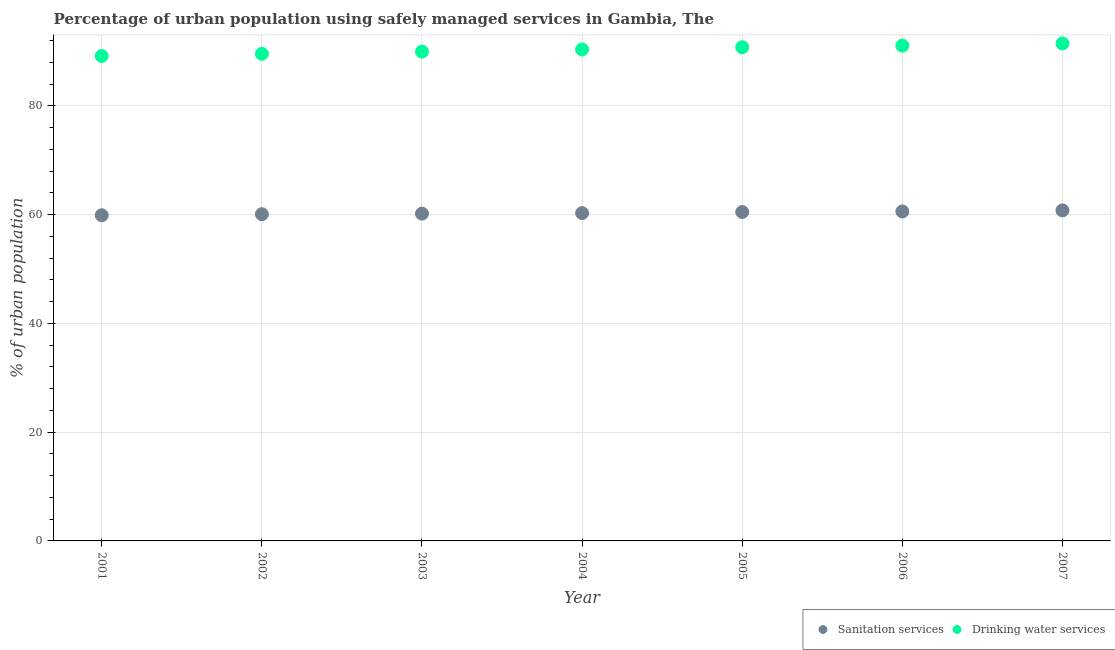What is the percentage of urban population who used drinking water services in 2006?
Make the answer very short. 91.1. Across all years, what is the maximum percentage of urban population who used sanitation services?
Make the answer very short. 60.8. Across all years, what is the minimum percentage of urban population who used drinking water services?
Your answer should be compact. 89.2. What is the total percentage of urban population who used drinking water services in the graph?
Offer a very short reply. 632.6. What is the difference between the percentage of urban population who used drinking water services in 2006 and that in 2007?
Your answer should be very brief. -0.4. What is the difference between the percentage of urban population who used drinking water services in 2003 and the percentage of urban population who used sanitation services in 2001?
Give a very brief answer. 30.1. What is the average percentage of urban population who used sanitation services per year?
Give a very brief answer. 60.34. In the year 2001, what is the difference between the percentage of urban population who used drinking water services and percentage of urban population who used sanitation services?
Keep it short and to the point. 29.3. In how many years, is the percentage of urban population who used drinking water services greater than 28 %?
Give a very brief answer. 7. What is the ratio of the percentage of urban population who used sanitation services in 2001 to that in 2006?
Give a very brief answer. 0.99. Is the percentage of urban population who used sanitation services in 2002 less than that in 2004?
Keep it short and to the point. Yes. Is the difference between the percentage of urban population who used sanitation services in 2004 and 2005 greater than the difference between the percentage of urban population who used drinking water services in 2004 and 2005?
Offer a very short reply. Yes. What is the difference between the highest and the second highest percentage of urban population who used sanitation services?
Your answer should be very brief. 0.2. What is the difference between the highest and the lowest percentage of urban population who used sanitation services?
Your answer should be compact. 0.9. Does the percentage of urban population who used sanitation services monotonically increase over the years?
Make the answer very short. Yes. How many dotlines are there?
Provide a short and direct response. 2. Does the graph contain grids?
Make the answer very short. Yes. How many legend labels are there?
Your answer should be very brief. 2. How are the legend labels stacked?
Your response must be concise. Horizontal. What is the title of the graph?
Your answer should be very brief. Percentage of urban population using safely managed services in Gambia, The. What is the label or title of the X-axis?
Provide a short and direct response. Year. What is the label or title of the Y-axis?
Your answer should be very brief. % of urban population. What is the % of urban population in Sanitation services in 2001?
Your response must be concise. 59.9. What is the % of urban population of Drinking water services in 2001?
Your response must be concise. 89.2. What is the % of urban population in Sanitation services in 2002?
Your response must be concise. 60.1. What is the % of urban population in Drinking water services in 2002?
Provide a short and direct response. 89.6. What is the % of urban population of Sanitation services in 2003?
Provide a succinct answer. 60.2. What is the % of urban population of Drinking water services in 2003?
Ensure brevity in your answer.  90. What is the % of urban population in Sanitation services in 2004?
Your answer should be very brief. 60.3. What is the % of urban population in Drinking water services in 2004?
Provide a succinct answer. 90.4. What is the % of urban population of Sanitation services in 2005?
Give a very brief answer. 60.5. What is the % of urban population in Drinking water services in 2005?
Provide a succinct answer. 90.8. What is the % of urban population in Sanitation services in 2006?
Your response must be concise. 60.6. What is the % of urban population in Drinking water services in 2006?
Offer a terse response. 91.1. What is the % of urban population of Sanitation services in 2007?
Ensure brevity in your answer.  60.8. What is the % of urban population in Drinking water services in 2007?
Make the answer very short. 91.5. Across all years, what is the maximum % of urban population of Sanitation services?
Keep it short and to the point. 60.8. Across all years, what is the maximum % of urban population of Drinking water services?
Your answer should be compact. 91.5. Across all years, what is the minimum % of urban population in Sanitation services?
Provide a short and direct response. 59.9. Across all years, what is the minimum % of urban population of Drinking water services?
Your answer should be very brief. 89.2. What is the total % of urban population of Sanitation services in the graph?
Ensure brevity in your answer.  422.4. What is the total % of urban population in Drinking water services in the graph?
Provide a short and direct response. 632.6. What is the difference between the % of urban population of Sanitation services in 2001 and that in 2002?
Ensure brevity in your answer.  -0.2. What is the difference between the % of urban population in Drinking water services in 2001 and that in 2002?
Provide a succinct answer. -0.4. What is the difference between the % of urban population of Sanitation services in 2001 and that in 2003?
Your answer should be compact. -0.3. What is the difference between the % of urban population of Sanitation services in 2001 and that in 2004?
Ensure brevity in your answer.  -0.4. What is the difference between the % of urban population of Sanitation services in 2001 and that in 2005?
Offer a very short reply. -0.6. What is the difference between the % of urban population of Drinking water services in 2001 and that in 2005?
Offer a terse response. -1.6. What is the difference between the % of urban population of Drinking water services in 2001 and that in 2006?
Keep it short and to the point. -1.9. What is the difference between the % of urban population in Drinking water services in 2002 and that in 2003?
Your answer should be compact. -0.4. What is the difference between the % of urban population of Sanitation services in 2002 and that in 2004?
Your answer should be compact. -0.2. What is the difference between the % of urban population of Drinking water services in 2002 and that in 2004?
Your response must be concise. -0.8. What is the difference between the % of urban population in Sanitation services in 2002 and that in 2005?
Offer a very short reply. -0.4. What is the difference between the % of urban population of Sanitation services in 2002 and that in 2006?
Give a very brief answer. -0.5. What is the difference between the % of urban population of Drinking water services in 2002 and that in 2006?
Offer a terse response. -1.5. What is the difference between the % of urban population in Drinking water services in 2002 and that in 2007?
Offer a very short reply. -1.9. What is the difference between the % of urban population in Drinking water services in 2003 and that in 2005?
Your answer should be compact. -0.8. What is the difference between the % of urban population of Sanitation services in 2003 and that in 2007?
Ensure brevity in your answer.  -0.6. What is the difference between the % of urban population of Drinking water services in 2003 and that in 2007?
Give a very brief answer. -1.5. What is the difference between the % of urban population of Drinking water services in 2004 and that in 2005?
Your answer should be very brief. -0.4. What is the difference between the % of urban population of Sanitation services in 2004 and that in 2007?
Offer a terse response. -0.5. What is the difference between the % of urban population of Drinking water services in 2004 and that in 2007?
Keep it short and to the point. -1.1. What is the difference between the % of urban population of Sanitation services in 2006 and that in 2007?
Your answer should be compact. -0.2. What is the difference between the % of urban population in Sanitation services in 2001 and the % of urban population in Drinking water services in 2002?
Offer a very short reply. -29.7. What is the difference between the % of urban population in Sanitation services in 2001 and the % of urban population in Drinking water services in 2003?
Provide a succinct answer. -30.1. What is the difference between the % of urban population of Sanitation services in 2001 and the % of urban population of Drinking water services in 2004?
Provide a short and direct response. -30.5. What is the difference between the % of urban population in Sanitation services in 2001 and the % of urban population in Drinking water services in 2005?
Your response must be concise. -30.9. What is the difference between the % of urban population in Sanitation services in 2001 and the % of urban population in Drinking water services in 2006?
Your response must be concise. -31.2. What is the difference between the % of urban population in Sanitation services in 2001 and the % of urban population in Drinking water services in 2007?
Make the answer very short. -31.6. What is the difference between the % of urban population in Sanitation services in 2002 and the % of urban population in Drinking water services in 2003?
Keep it short and to the point. -29.9. What is the difference between the % of urban population of Sanitation services in 2002 and the % of urban population of Drinking water services in 2004?
Provide a short and direct response. -30.3. What is the difference between the % of urban population of Sanitation services in 2002 and the % of urban population of Drinking water services in 2005?
Ensure brevity in your answer.  -30.7. What is the difference between the % of urban population in Sanitation services in 2002 and the % of urban population in Drinking water services in 2006?
Provide a short and direct response. -31. What is the difference between the % of urban population in Sanitation services in 2002 and the % of urban population in Drinking water services in 2007?
Ensure brevity in your answer.  -31.4. What is the difference between the % of urban population of Sanitation services in 2003 and the % of urban population of Drinking water services in 2004?
Your answer should be compact. -30.2. What is the difference between the % of urban population of Sanitation services in 2003 and the % of urban population of Drinking water services in 2005?
Provide a succinct answer. -30.6. What is the difference between the % of urban population of Sanitation services in 2003 and the % of urban population of Drinking water services in 2006?
Make the answer very short. -30.9. What is the difference between the % of urban population of Sanitation services in 2003 and the % of urban population of Drinking water services in 2007?
Ensure brevity in your answer.  -31.3. What is the difference between the % of urban population of Sanitation services in 2004 and the % of urban population of Drinking water services in 2005?
Your response must be concise. -30.5. What is the difference between the % of urban population of Sanitation services in 2004 and the % of urban population of Drinking water services in 2006?
Your answer should be very brief. -30.8. What is the difference between the % of urban population of Sanitation services in 2004 and the % of urban population of Drinking water services in 2007?
Provide a succinct answer. -31.2. What is the difference between the % of urban population in Sanitation services in 2005 and the % of urban population in Drinking water services in 2006?
Offer a terse response. -30.6. What is the difference between the % of urban population of Sanitation services in 2005 and the % of urban population of Drinking water services in 2007?
Provide a short and direct response. -31. What is the difference between the % of urban population of Sanitation services in 2006 and the % of urban population of Drinking water services in 2007?
Offer a very short reply. -30.9. What is the average % of urban population of Sanitation services per year?
Offer a very short reply. 60.34. What is the average % of urban population of Drinking water services per year?
Ensure brevity in your answer.  90.37. In the year 2001, what is the difference between the % of urban population of Sanitation services and % of urban population of Drinking water services?
Make the answer very short. -29.3. In the year 2002, what is the difference between the % of urban population in Sanitation services and % of urban population in Drinking water services?
Your answer should be very brief. -29.5. In the year 2003, what is the difference between the % of urban population in Sanitation services and % of urban population in Drinking water services?
Make the answer very short. -29.8. In the year 2004, what is the difference between the % of urban population in Sanitation services and % of urban population in Drinking water services?
Keep it short and to the point. -30.1. In the year 2005, what is the difference between the % of urban population of Sanitation services and % of urban population of Drinking water services?
Your answer should be compact. -30.3. In the year 2006, what is the difference between the % of urban population in Sanitation services and % of urban population in Drinking water services?
Your answer should be very brief. -30.5. In the year 2007, what is the difference between the % of urban population in Sanitation services and % of urban population in Drinking water services?
Provide a succinct answer. -30.7. What is the ratio of the % of urban population of Drinking water services in 2001 to that in 2002?
Make the answer very short. 1. What is the ratio of the % of urban population in Sanitation services in 2001 to that in 2003?
Provide a short and direct response. 0.99. What is the ratio of the % of urban population in Sanitation services in 2001 to that in 2004?
Keep it short and to the point. 0.99. What is the ratio of the % of urban population of Drinking water services in 2001 to that in 2004?
Offer a very short reply. 0.99. What is the ratio of the % of urban population of Drinking water services in 2001 to that in 2005?
Ensure brevity in your answer.  0.98. What is the ratio of the % of urban population of Sanitation services in 2001 to that in 2006?
Your answer should be very brief. 0.99. What is the ratio of the % of urban population of Drinking water services in 2001 to that in 2006?
Give a very brief answer. 0.98. What is the ratio of the % of urban population in Sanitation services in 2001 to that in 2007?
Provide a short and direct response. 0.99. What is the ratio of the % of urban population of Drinking water services in 2001 to that in 2007?
Offer a very short reply. 0.97. What is the ratio of the % of urban population in Sanitation services in 2002 to that in 2003?
Keep it short and to the point. 1. What is the ratio of the % of urban population of Drinking water services in 2002 to that in 2004?
Give a very brief answer. 0.99. What is the ratio of the % of urban population in Drinking water services in 2002 to that in 2006?
Provide a succinct answer. 0.98. What is the ratio of the % of urban population in Drinking water services in 2002 to that in 2007?
Provide a succinct answer. 0.98. What is the ratio of the % of urban population of Sanitation services in 2003 to that in 2004?
Keep it short and to the point. 1. What is the ratio of the % of urban population of Drinking water services in 2003 to that in 2005?
Make the answer very short. 0.99. What is the ratio of the % of urban population in Drinking water services in 2003 to that in 2006?
Keep it short and to the point. 0.99. What is the ratio of the % of urban population in Sanitation services in 2003 to that in 2007?
Your answer should be compact. 0.99. What is the ratio of the % of urban population of Drinking water services in 2003 to that in 2007?
Make the answer very short. 0.98. What is the ratio of the % of urban population in Sanitation services in 2004 to that in 2005?
Offer a very short reply. 1. What is the ratio of the % of urban population in Drinking water services in 2004 to that in 2006?
Your response must be concise. 0.99. What is the ratio of the % of urban population of Sanitation services in 2004 to that in 2007?
Your answer should be compact. 0.99. What is the ratio of the % of urban population of Drinking water services in 2004 to that in 2007?
Give a very brief answer. 0.99. What is the ratio of the % of urban population in Sanitation services in 2005 to that in 2006?
Your answer should be very brief. 1. What is the ratio of the % of urban population in Sanitation services in 2005 to that in 2007?
Provide a succinct answer. 1. What is the ratio of the % of urban population of Drinking water services in 2005 to that in 2007?
Offer a terse response. 0.99. What is the difference between the highest and the second highest % of urban population of Sanitation services?
Make the answer very short. 0.2. What is the difference between the highest and the second highest % of urban population in Drinking water services?
Keep it short and to the point. 0.4. 